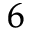Convert formula to latex. <formula><loc_0><loc_0><loc_500><loc_500>^ { 6 }</formula> 